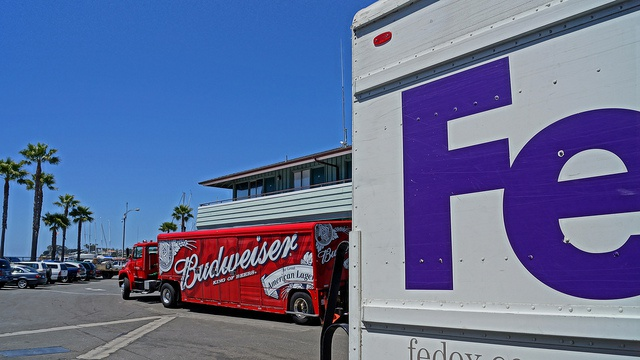Describe the objects in this image and their specific colors. I can see truck in blue, darkgray, navy, darkblue, and lightgray tones, truck in blue, black, brown, maroon, and darkgray tones, car in blue, black, gray, and darkgray tones, car in blue, black, navy, and gray tones, and car in blue, black, gray, and navy tones in this image. 